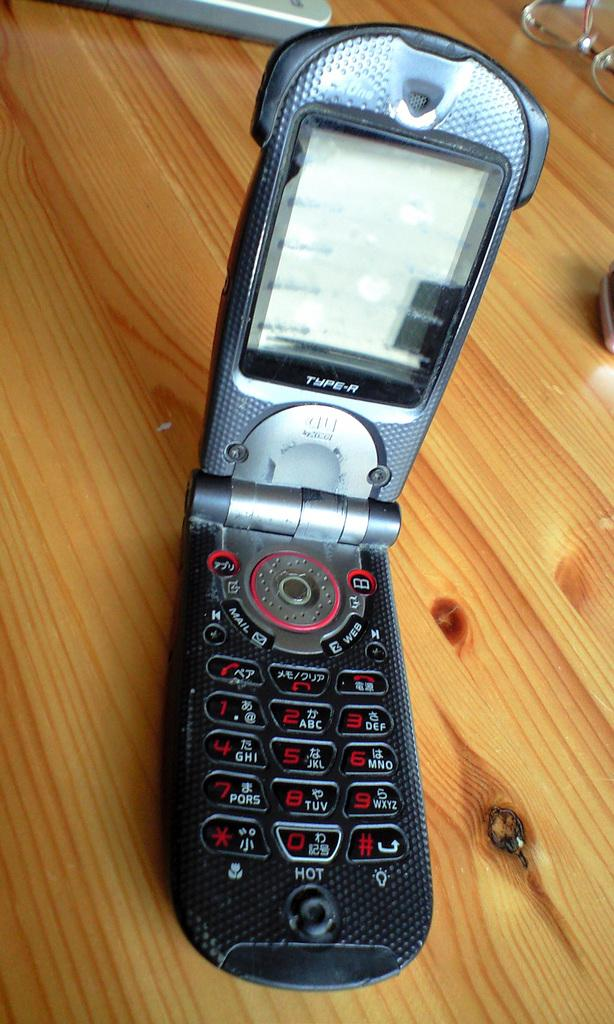What is the main object on the wooden table in the image? There is a mobile phone on a wooden table in the image. Can you describe the object at the top of the image? There is an object that resembles a remote at the top of the image. What can be seen on the top right side of the image? There are spectacles on the top right side of the image. How does the mobile phone participate in the fight happening in the image? There is no fight happening in the image, and the mobile phone is not participating in any such event. 